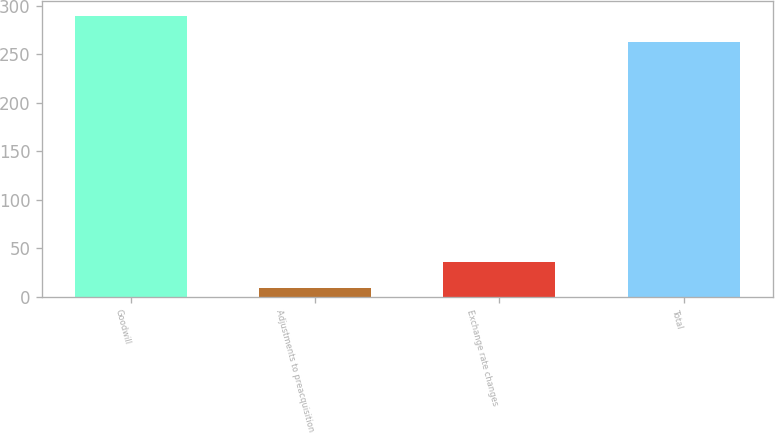Convert chart. <chart><loc_0><loc_0><loc_500><loc_500><bar_chart><fcel>Goodwill<fcel>Adjustments to preacquisition<fcel>Exchange rate changes<fcel>Total<nl><fcel>289.8<fcel>9<fcel>35.8<fcel>263<nl></chart> 